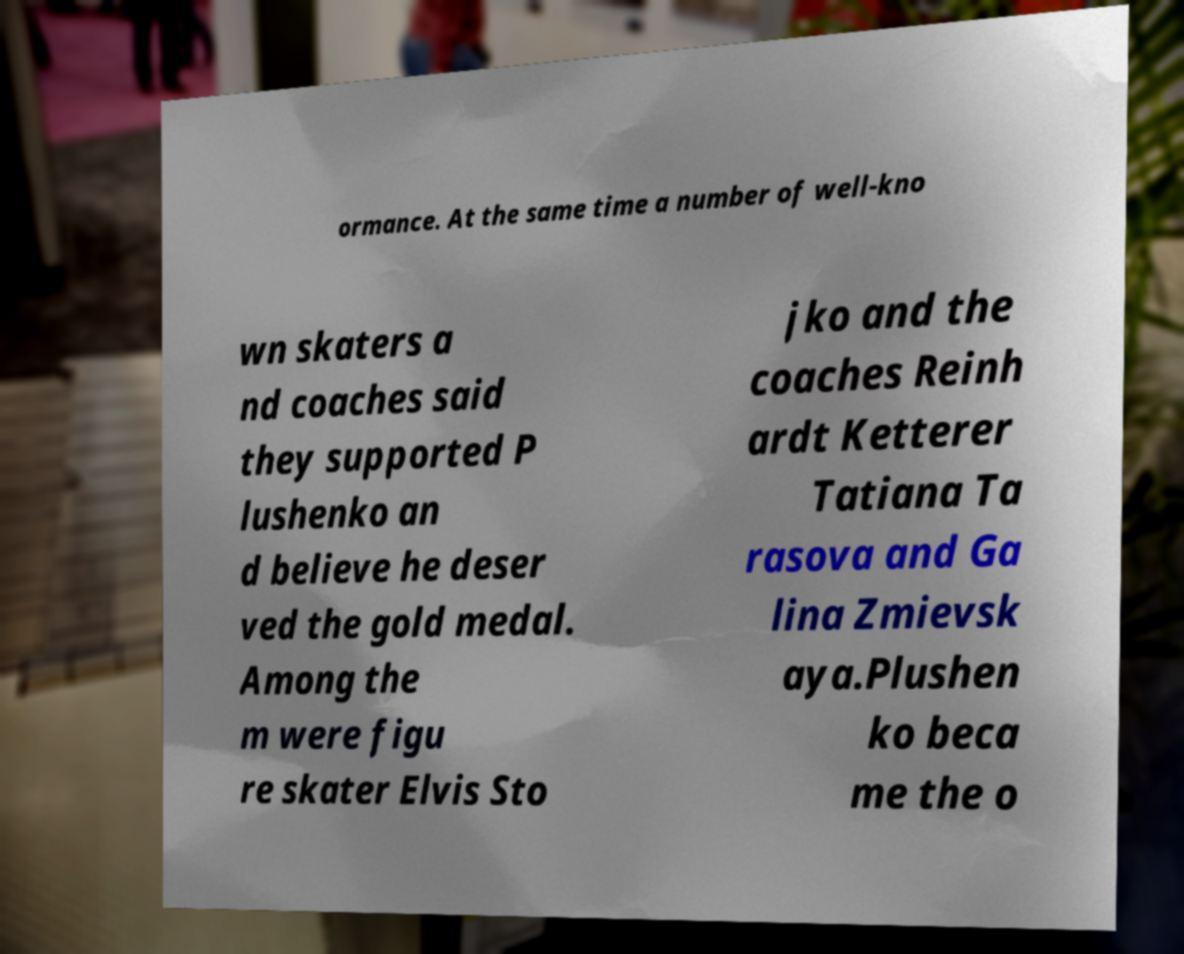Can you accurately transcribe the text from the provided image for me? ormance. At the same time a number of well-kno wn skaters a nd coaches said they supported P lushenko an d believe he deser ved the gold medal. Among the m were figu re skater Elvis Sto jko and the coaches Reinh ardt Ketterer Tatiana Ta rasova and Ga lina Zmievsk aya.Plushen ko beca me the o 